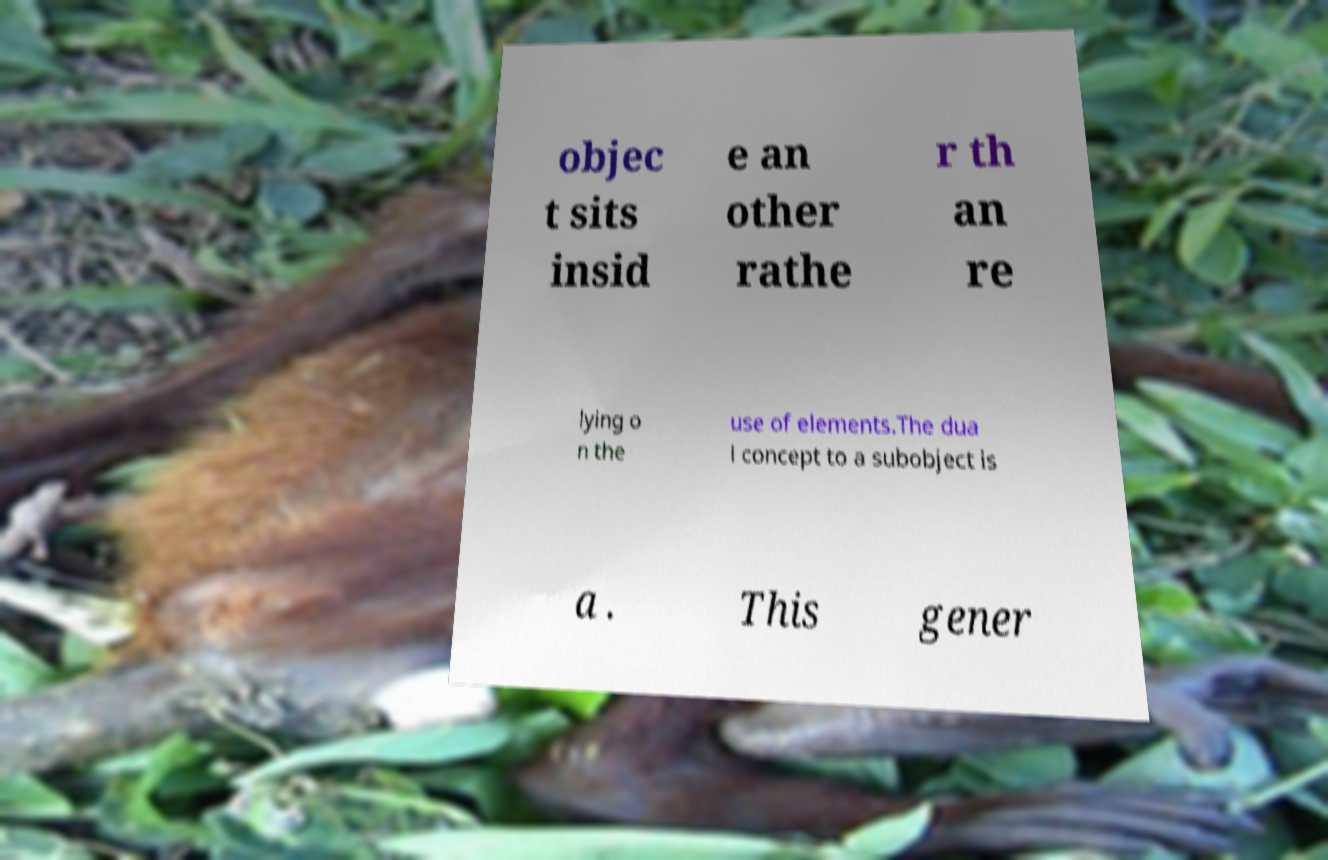For documentation purposes, I need the text within this image transcribed. Could you provide that? objec t sits insid e an other rathe r th an re lying o n the use of elements.The dua l concept to a subobject is a . This gener 